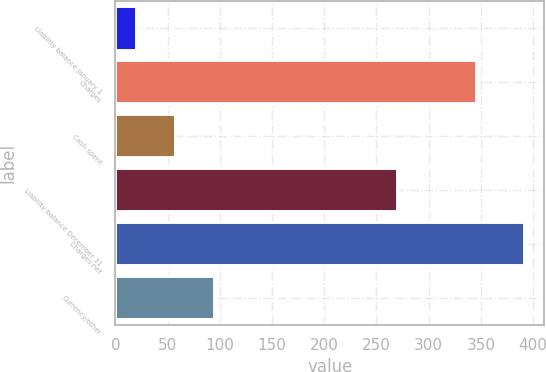Convert chart to OTSL. <chart><loc_0><loc_0><loc_500><loc_500><bar_chart><fcel>Liability balance January 1<fcel>Charges<fcel>Cash spent<fcel>Liability balance December 31<fcel>Charges net<fcel>Currency/other<nl><fcel>20<fcel>345.1<fcel>57.1<fcel>270<fcel>391<fcel>94.2<nl></chart> 